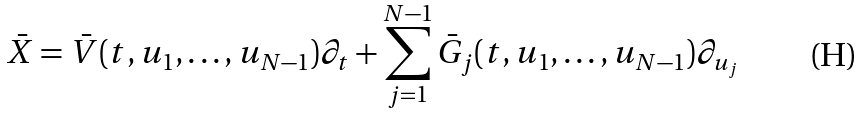Convert formula to latex. <formula><loc_0><loc_0><loc_500><loc_500>\bar { X } = \bar { V } ( t , u _ { 1 } , \dots , u _ { N - 1 } ) \partial _ { t } + \sum ^ { N - 1 } _ { j = 1 } \bar { G } _ { j } ( t , u _ { 1 } , \dots , u _ { N - 1 } ) \partial _ { u _ { j } }</formula> 